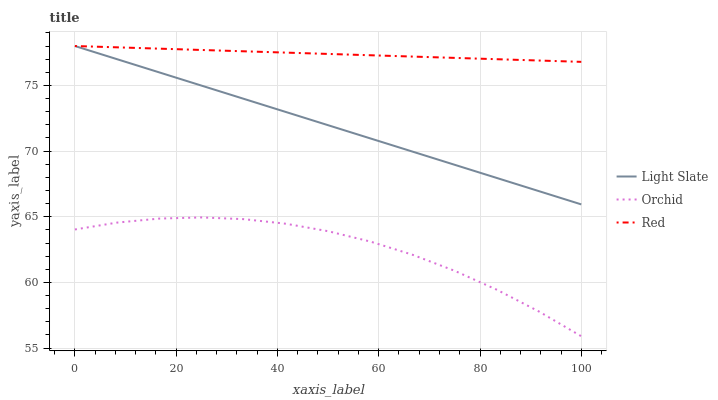Does Orchid have the minimum area under the curve?
Answer yes or no. Yes. Does Red have the maximum area under the curve?
Answer yes or no. Yes. Does Red have the minimum area under the curve?
Answer yes or no. No. Does Orchid have the maximum area under the curve?
Answer yes or no. No. Is Red the smoothest?
Answer yes or no. Yes. Is Orchid the roughest?
Answer yes or no. Yes. Is Orchid the smoothest?
Answer yes or no. No. Is Red the roughest?
Answer yes or no. No. Does Orchid have the lowest value?
Answer yes or no. Yes. Does Red have the lowest value?
Answer yes or no. No. Does Red have the highest value?
Answer yes or no. Yes. Does Orchid have the highest value?
Answer yes or no. No. Is Orchid less than Red?
Answer yes or no. Yes. Is Light Slate greater than Orchid?
Answer yes or no. Yes. Does Red intersect Light Slate?
Answer yes or no. Yes. Is Red less than Light Slate?
Answer yes or no. No. Is Red greater than Light Slate?
Answer yes or no. No. Does Orchid intersect Red?
Answer yes or no. No. 